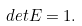Convert formula to latex. <formula><loc_0><loc_0><loc_500><loc_500>d e t E = 1 .</formula> 